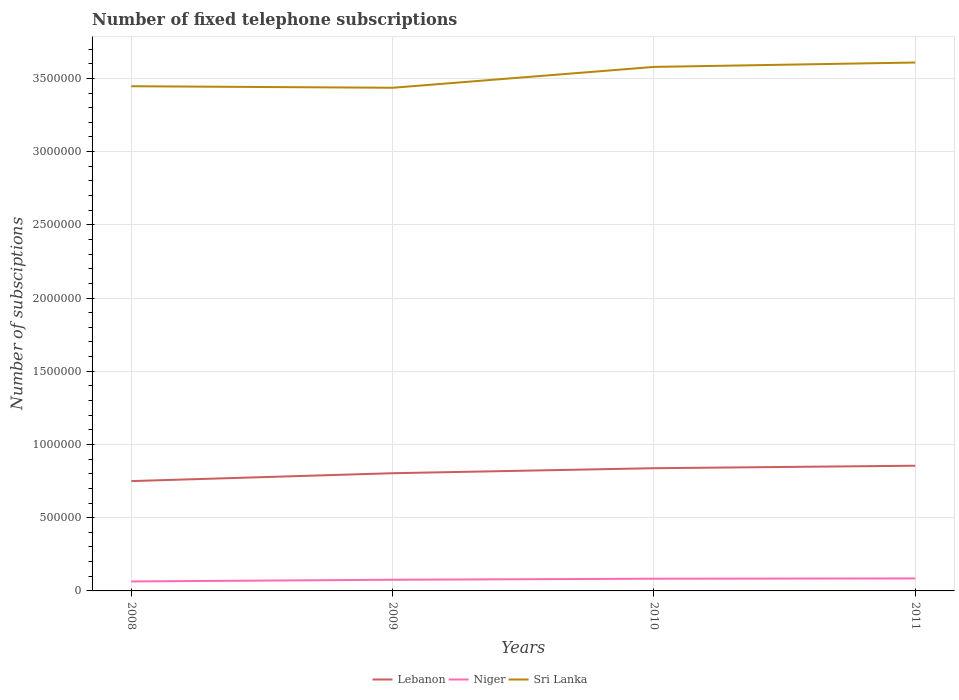How many different coloured lines are there?
Offer a very short reply. 3. Does the line corresponding to Sri Lanka intersect with the line corresponding to Lebanon?
Give a very brief answer. No. Across all years, what is the maximum number of fixed telephone subscriptions in Sri Lanka?
Keep it short and to the point. 3.44e+06. What is the total number of fixed telephone subscriptions in Lebanon in the graph?
Provide a short and direct response. -3.43e+04. What is the difference between the highest and the second highest number of fixed telephone subscriptions in Lebanon?
Offer a terse response. 1.05e+05. Is the number of fixed telephone subscriptions in Sri Lanka strictly greater than the number of fixed telephone subscriptions in Niger over the years?
Your response must be concise. No. How many lines are there?
Ensure brevity in your answer.  3. What is the difference between two consecutive major ticks on the Y-axis?
Provide a short and direct response. 5.00e+05. Are the values on the major ticks of Y-axis written in scientific E-notation?
Your answer should be compact. No. What is the title of the graph?
Ensure brevity in your answer.  Number of fixed telephone subscriptions. Does "Palau" appear as one of the legend labels in the graph?
Provide a succinct answer. No. What is the label or title of the X-axis?
Offer a terse response. Years. What is the label or title of the Y-axis?
Make the answer very short. Number of subsciptions. What is the Number of subsciptions in Lebanon in 2008?
Your answer should be compact. 7.50e+05. What is the Number of subsciptions in Niger in 2008?
Give a very brief answer. 6.47e+04. What is the Number of subsciptions in Sri Lanka in 2008?
Make the answer very short. 3.45e+06. What is the Number of subsciptions of Lebanon in 2009?
Ensure brevity in your answer.  8.04e+05. What is the Number of subsciptions of Niger in 2009?
Your answer should be very brief. 7.63e+04. What is the Number of subsciptions in Sri Lanka in 2009?
Make the answer very short. 3.44e+06. What is the Number of subsciptions of Lebanon in 2010?
Your response must be concise. 8.38e+05. What is the Number of subsciptions in Niger in 2010?
Your answer should be compact. 8.34e+04. What is the Number of subsciptions of Sri Lanka in 2010?
Offer a very short reply. 3.58e+06. What is the Number of subsciptions in Lebanon in 2011?
Give a very brief answer. 8.55e+05. What is the Number of subsciptions of Niger in 2011?
Make the answer very short. 8.54e+04. What is the Number of subsciptions of Sri Lanka in 2011?
Make the answer very short. 3.61e+06. Across all years, what is the maximum Number of subsciptions in Lebanon?
Offer a very short reply. 8.55e+05. Across all years, what is the maximum Number of subsciptions of Niger?
Keep it short and to the point. 8.54e+04. Across all years, what is the maximum Number of subsciptions of Sri Lanka?
Provide a succinct answer. 3.61e+06. Across all years, what is the minimum Number of subsciptions in Lebanon?
Keep it short and to the point. 7.50e+05. Across all years, what is the minimum Number of subsciptions of Niger?
Your answer should be compact. 6.47e+04. Across all years, what is the minimum Number of subsciptions in Sri Lanka?
Offer a terse response. 3.44e+06. What is the total Number of subsciptions of Lebanon in the graph?
Make the answer very short. 3.25e+06. What is the total Number of subsciptions of Niger in the graph?
Keep it short and to the point. 3.10e+05. What is the total Number of subsciptions of Sri Lanka in the graph?
Keep it short and to the point. 1.41e+07. What is the difference between the Number of subsciptions of Lebanon in 2008 and that in 2009?
Offer a very short reply. -5.37e+04. What is the difference between the Number of subsciptions in Niger in 2008 and that in 2009?
Provide a succinct answer. -1.16e+04. What is the difference between the Number of subsciptions in Sri Lanka in 2008 and that in 2009?
Make the answer very short. 1.05e+04. What is the difference between the Number of subsciptions in Lebanon in 2008 and that in 2010?
Offer a very short reply. -8.80e+04. What is the difference between the Number of subsciptions in Niger in 2008 and that in 2010?
Offer a terse response. -1.86e+04. What is the difference between the Number of subsciptions in Sri Lanka in 2008 and that in 2010?
Your response must be concise. -1.32e+05. What is the difference between the Number of subsciptions in Lebanon in 2008 and that in 2011?
Your answer should be very brief. -1.05e+05. What is the difference between the Number of subsciptions in Niger in 2008 and that in 2011?
Offer a terse response. -2.06e+04. What is the difference between the Number of subsciptions of Sri Lanka in 2008 and that in 2011?
Keep it short and to the point. -1.62e+05. What is the difference between the Number of subsciptions of Lebanon in 2009 and that in 2010?
Your response must be concise. -3.43e+04. What is the difference between the Number of subsciptions in Niger in 2009 and that in 2010?
Offer a very short reply. -7047. What is the difference between the Number of subsciptions of Sri Lanka in 2009 and that in 2010?
Keep it short and to the point. -1.43e+05. What is the difference between the Number of subsciptions in Lebanon in 2009 and that in 2011?
Give a very brief answer. -5.13e+04. What is the difference between the Number of subsciptions of Niger in 2009 and that in 2011?
Provide a short and direct response. -9018. What is the difference between the Number of subsciptions in Sri Lanka in 2009 and that in 2011?
Offer a terse response. -1.72e+05. What is the difference between the Number of subsciptions of Lebanon in 2010 and that in 2011?
Offer a very short reply. -1.70e+04. What is the difference between the Number of subsciptions of Niger in 2010 and that in 2011?
Give a very brief answer. -1971. What is the difference between the Number of subsciptions of Sri Lanka in 2010 and that in 2011?
Offer a terse response. -2.99e+04. What is the difference between the Number of subsciptions in Lebanon in 2008 and the Number of subsciptions in Niger in 2009?
Provide a succinct answer. 6.74e+05. What is the difference between the Number of subsciptions of Lebanon in 2008 and the Number of subsciptions of Sri Lanka in 2009?
Offer a terse response. -2.69e+06. What is the difference between the Number of subsciptions in Niger in 2008 and the Number of subsciptions in Sri Lanka in 2009?
Provide a succinct answer. -3.37e+06. What is the difference between the Number of subsciptions in Lebanon in 2008 and the Number of subsciptions in Niger in 2010?
Provide a short and direct response. 6.67e+05. What is the difference between the Number of subsciptions in Lebanon in 2008 and the Number of subsciptions in Sri Lanka in 2010?
Offer a very short reply. -2.83e+06. What is the difference between the Number of subsciptions of Niger in 2008 and the Number of subsciptions of Sri Lanka in 2010?
Offer a terse response. -3.51e+06. What is the difference between the Number of subsciptions in Lebanon in 2008 and the Number of subsciptions in Niger in 2011?
Offer a terse response. 6.65e+05. What is the difference between the Number of subsciptions of Lebanon in 2008 and the Number of subsciptions of Sri Lanka in 2011?
Ensure brevity in your answer.  -2.86e+06. What is the difference between the Number of subsciptions in Niger in 2008 and the Number of subsciptions in Sri Lanka in 2011?
Give a very brief answer. -3.54e+06. What is the difference between the Number of subsciptions of Lebanon in 2009 and the Number of subsciptions of Niger in 2010?
Make the answer very short. 7.20e+05. What is the difference between the Number of subsciptions in Lebanon in 2009 and the Number of subsciptions in Sri Lanka in 2010?
Give a very brief answer. -2.77e+06. What is the difference between the Number of subsciptions in Niger in 2009 and the Number of subsciptions in Sri Lanka in 2010?
Make the answer very short. -3.50e+06. What is the difference between the Number of subsciptions in Lebanon in 2009 and the Number of subsciptions in Niger in 2011?
Provide a short and direct response. 7.18e+05. What is the difference between the Number of subsciptions in Lebanon in 2009 and the Number of subsciptions in Sri Lanka in 2011?
Your answer should be compact. -2.80e+06. What is the difference between the Number of subsciptions in Niger in 2009 and the Number of subsciptions in Sri Lanka in 2011?
Ensure brevity in your answer.  -3.53e+06. What is the difference between the Number of subsciptions in Lebanon in 2010 and the Number of subsciptions in Niger in 2011?
Your answer should be very brief. 7.53e+05. What is the difference between the Number of subsciptions in Lebanon in 2010 and the Number of subsciptions in Sri Lanka in 2011?
Ensure brevity in your answer.  -2.77e+06. What is the difference between the Number of subsciptions of Niger in 2010 and the Number of subsciptions of Sri Lanka in 2011?
Offer a very short reply. -3.53e+06. What is the average Number of subsciptions of Lebanon per year?
Keep it short and to the point. 8.12e+05. What is the average Number of subsciptions of Niger per year?
Your answer should be very brief. 7.75e+04. What is the average Number of subsciptions of Sri Lanka per year?
Your response must be concise. 3.52e+06. In the year 2008, what is the difference between the Number of subsciptions of Lebanon and Number of subsciptions of Niger?
Make the answer very short. 6.85e+05. In the year 2008, what is the difference between the Number of subsciptions of Lebanon and Number of subsciptions of Sri Lanka?
Your answer should be compact. -2.70e+06. In the year 2008, what is the difference between the Number of subsciptions of Niger and Number of subsciptions of Sri Lanka?
Make the answer very short. -3.38e+06. In the year 2009, what is the difference between the Number of subsciptions of Lebanon and Number of subsciptions of Niger?
Give a very brief answer. 7.27e+05. In the year 2009, what is the difference between the Number of subsciptions in Lebanon and Number of subsciptions in Sri Lanka?
Keep it short and to the point. -2.63e+06. In the year 2009, what is the difference between the Number of subsciptions in Niger and Number of subsciptions in Sri Lanka?
Keep it short and to the point. -3.36e+06. In the year 2010, what is the difference between the Number of subsciptions of Lebanon and Number of subsciptions of Niger?
Give a very brief answer. 7.55e+05. In the year 2010, what is the difference between the Number of subsciptions in Lebanon and Number of subsciptions in Sri Lanka?
Ensure brevity in your answer.  -2.74e+06. In the year 2010, what is the difference between the Number of subsciptions in Niger and Number of subsciptions in Sri Lanka?
Ensure brevity in your answer.  -3.50e+06. In the year 2011, what is the difference between the Number of subsciptions of Lebanon and Number of subsciptions of Niger?
Your answer should be very brief. 7.70e+05. In the year 2011, what is the difference between the Number of subsciptions of Lebanon and Number of subsciptions of Sri Lanka?
Provide a succinct answer. -2.75e+06. In the year 2011, what is the difference between the Number of subsciptions in Niger and Number of subsciptions in Sri Lanka?
Provide a succinct answer. -3.52e+06. What is the ratio of the Number of subsciptions in Lebanon in 2008 to that in 2009?
Keep it short and to the point. 0.93. What is the ratio of the Number of subsciptions of Niger in 2008 to that in 2009?
Keep it short and to the point. 0.85. What is the ratio of the Number of subsciptions in Lebanon in 2008 to that in 2010?
Provide a succinct answer. 0.9. What is the ratio of the Number of subsciptions of Niger in 2008 to that in 2010?
Give a very brief answer. 0.78. What is the ratio of the Number of subsciptions of Sri Lanka in 2008 to that in 2010?
Ensure brevity in your answer.  0.96. What is the ratio of the Number of subsciptions of Lebanon in 2008 to that in 2011?
Your answer should be very brief. 0.88. What is the ratio of the Number of subsciptions of Niger in 2008 to that in 2011?
Your answer should be very brief. 0.76. What is the ratio of the Number of subsciptions in Sri Lanka in 2008 to that in 2011?
Ensure brevity in your answer.  0.96. What is the ratio of the Number of subsciptions in Lebanon in 2009 to that in 2010?
Your response must be concise. 0.96. What is the ratio of the Number of subsciptions of Niger in 2009 to that in 2010?
Make the answer very short. 0.92. What is the ratio of the Number of subsciptions of Sri Lanka in 2009 to that in 2010?
Offer a terse response. 0.96. What is the ratio of the Number of subsciptions of Lebanon in 2009 to that in 2011?
Offer a very short reply. 0.94. What is the ratio of the Number of subsciptions in Niger in 2009 to that in 2011?
Provide a short and direct response. 0.89. What is the ratio of the Number of subsciptions in Sri Lanka in 2009 to that in 2011?
Offer a terse response. 0.95. What is the ratio of the Number of subsciptions of Lebanon in 2010 to that in 2011?
Ensure brevity in your answer.  0.98. What is the ratio of the Number of subsciptions of Niger in 2010 to that in 2011?
Ensure brevity in your answer.  0.98. What is the difference between the highest and the second highest Number of subsciptions of Lebanon?
Your response must be concise. 1.70e+04. What is the difference between the highest and the second highest Number of subsciptions of Niger?
Provide a short and direct response. 1971. What is the difference between the highest and the second highest Number of subsciptions in Sri Lanka?
Provide a succinct answer. 2.99e+04. What is the difference between the highest and the lowest Number of subsciptions of Lebanon?
Your answer should be very brief. 1.05e+05. What is the difference between the highest and the lowest Number of subsciptions of Niger?
Your answer should be compact. 2.06e+04. What is the difference between the highest and the lowest Number of subsciptions of Sri Lanka?
Your answer should be compact. 1.72e+05. 